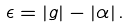<formula> <loc_0><loc_0><loc_500><loc_500>\epsilon = | g | - | \alpha | \, .</formula> 